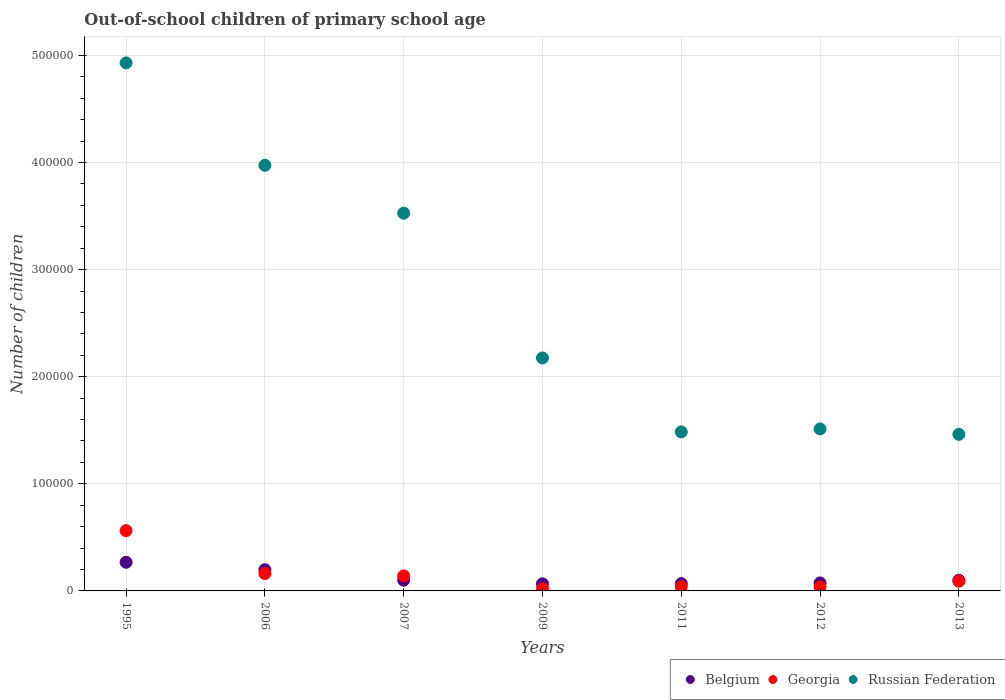What is the number of out-of-school children in Georgia in 2011?
Your answer should be very brief. 3975. Across all years, what is the maximum number of out-of-school children in Georgia?
Provide a succinct answer. 5.63e+04. Across all years, what is the minimum number of out-of-school children in Belgium?
Give a very brief answer. 6647. In which year was the number of out-of-school children in Russian Federation maximum?
Keep it short and to the point. 1995. What is the total number of out-of-school children in Belgium in the graph?
Your answer should be compact. 8.75e+04. What is the difference between the number of out-of-school children in Russian Federation in 1995 and that in 2013?
Your answer should be very brief. 3.47e+05. What is the difference between the number of out-of-school children in Georgia in 2006 and the number of out-of-school children in Russian Federation in 2007?
Give a very brief answer. -3.36e+05. What is the average number of out-of-school children in Georgia per year?
Your answer should be very brief. 1.50e+04. In the year 2013, what is the difference between the number of out-of-school children in Russian Federation and number of out-of-school children in Georgia?
Provide a short and direct response. 1.37e+05. What is the ratio of the number of out-of-school children in Russian Federation in 2006 to that in 2007?
Your answer should be very brief. 1.13. Is the difference between the number of out-of-school children in Russian Federation in 2009 and 2012 greater than the difference between the number of out-of-school children in Georgia in 2009 and 2012?
Give a very brief answer. Yes. What is the difference between the highest and the second highest number of out-of-school children in Russian Federation?
Your answer should be very brief. 9.57e+04. What is the difference between the highest and the lowest number of out-of-school children in Russian Federation?
Provide a short and direct response. 3.47e+05. Is the sum of the number of out-of-school children in Georgia in 1995 and 2009 greater than the maximum number of out-of-school children in Belgium across all years?
Your answer should be compact. Yes. Is it the case that in every year, the sum of the number of out-of-school children in Belgium and number of out-of-school children in Georgia  is greater than the number of out-of-school children in Russian Federation?
Your answer should be compact. No. Does the number of out-of-school children in Georgia monotonically increase over the years?
Provide a short and direct response. No. Is the number of out-of-school children in Russian Federation strictly greater than the number of out-of-school children in Belgium over the years?
Keep it short and to the point. Yes. Is the number of out-of-school children in Georgia strictly less than the number of out-of-school children in Russian Federation over the years?
Keep it short and to the point. Yes. How many dotlines are there?
Your answer should be very brief. 3. How many years are there in the graph?
Your answer should be very brief. 7. Where does the legend appear in the graph?
Offer a very short reply. Bottom right. What is the title of the graph?
Ensure brevity in your answer.  Out-of-school children of primary school age. Does "Latvia" appear as one of the legend labels in the graph?
Ensure brevity in your answer.  No. What is the label or title of the X-axis?
Provide a short and direct response. Years. What is the label or title of the Y-axis?
Keep it short and to the point. Number of children. What is the Number of children in Belgium in 1995?
Ensure brevity in your answer.  2.68e+04. What is the Number of children of Georgia in 1995?
Offer a very short reply. 5.63e+04. What is the Number of children in Russian Federation in 1995?
Provide a succinct answer. 4.93e+05. What is the Number of children of Belgium in 2006?
Your response must be concise. 1.98e+04. What is the Number of children in Georgia in 2006?
Keep it short and to the point. 1.63e+04. What is the Number of children of Russian Federation in 2006?
Provide a succinct answer. 3.97e+05. What is the Number of children in Belgium in 2007?
Your answer should be very brief. 1.00e+04. What is the Number of children in Georgia in 2007?
Your response must be concise. 1.40e+04. What is the Number of children of Russian Federation in 2007?
Provide a short and direct response. 3.53e+05. What is the Number of children of Belgium in 2009?
Offer a terse response. 6647. What is the Number of children of Georgia in 2009?
Your response must be concise. 1934. What is the Number of children of Russian Federation in 2009?
Ensure brevity in your answer.  2.18e+05. What is the Number of children in Belgium in 2011?
Keep it short and to the point. 6830. What is the Number of children of Georgia in 2011?
Keep it short and to the point. 3975. What is the Number of children of Russian Federation in 2011?
Provide a succinct answer. 1.48e+05. What is the Number of children in Belgium in 2012?
Provide a short and direct response. 7427. What is the Number of children in Georgia in 2012?
Your answer should be very brief. 3772. What is the Number of children in Russian Federation in 2012?
Your response must be concise. 1.51e+05. What is the Number of children of Belgium in 2013?
Ensure brevity in your answer.  9981. What is the Number of children in Georgia in 2013?
Your response must be concise. 9082. What is the Number of children in Russian Federation in 2013?
Provide a succinct answer. 1.46e+05. Across all years, what is the maximum Number of children in Belgium?
Offer a very short reply. 2.68e+04. Across all years, what is the maximum Number of children of Georgia?
Offer a terse response. 5.63e+04. Across all years, what is the maximum Number of children in Russian Federation?
Make the answer very short. 4.93e+05. Across all years, what is the minimum Number of children of Belgium?
Make the answer very short. 6647. Across all years, what is the minimum Number of children in Georgia?
Your answer should be compact. 1934. Across all years, what is the minimum Number of children in Russian Federation?
Keep it short and to the point. 1.46e+05. What is the total Number of children of Belgium in the graph?
Your answer should be compact. 8.75e+04. What is the total Number of children of Georgia in the graph?
Give a very brief answer. 1.05e+05. What is the total Number of children in Russian Federation in the graph?
Provide a succinct answer. 1.91e+06. What is the difference between the Number of children in Belgium in 1995 and that in 2006?
Your response must be concise. 6946. What is the difference between the Number of children in Georgia in 1995 and that in 2006?
Offer a terse response. 4.00e+04. What is the difference between the Number of children of Russian Federation in 1995 and that in 2006?
Your answer should be compact. 9.57e+04. What is the difference between the Number of children of Belgium in 1995 and that in 2007?
Offer a very short reply. 1.67e+04. What is the difference between the Number of children of Georgia in 1995 and that in 2007?
Offer a terse response. 4.22e+04. What is the difference between the Number of children of Russian Federation in 1995 and that in 2007?
Your answer should be compact. 1.40e+05. What is the difference between the Number of children of Belgium in 1995 and that in 2009?
Give a very brief answer. 2.01e+04. What is the difference between the Number of children of Georgia in 1995 and that in 2009?
Offer a terse response. 5.43e+04. What is the difference between the Number of children in Russian Federation in 1995 and that in 2009?
Offer a terse response. 2.76e+05. What is the difference between the Number of children of Belgium in 1995 and that in 2011?
Your answer should be very brief. 1.99e+04. What is the difference between the Number of children in Georgia in 1995 and that in 2011?
Offer a terse response. 5.23e+04. What is the difference between the Number of children in Russian Federation in 1995 and that in 2011?
Make the answer very short. 3.45e+05. What is the difference between the Number of children of Belgium in 1995 and that in 2012?
Make the answer very short. 1.93e+04. What is the difference between the Number of children of Georgia in 1995 and that in 2012?
Your answer should be very brief. 5.25e+04. What is the difference between the Number of children in Russian Federation in 1995 and that in 2012?
Offer a terse response. 3.42e+05. What is the difference between the Number of children in Belgium in 1995 and that in 2013?
Your answer should be compact. 1.68e+04. What is the difference between the Number of children in Georgia in 1995 and that in 2013?
Your response must be concise. 4.72e+04. What is the difference between the Number of children in Russian Federation in 1995 and that in 2013?
Offer a very short reply. 3.47e+05. What is the difference between the Number of children of Belgium in 2006 and that in 2007?
Offer a very short reply. 9786. What is the difference between the Number of children in Georgia in 2006 and that in 2007?
Offer a very short reply. 2213. What is the difference between the Number of children of Russian Federation in 2006 and that in 2007?
Ensure brevity in your answer.  4.47e+04. What is the difference between the Number of children of Belgium in 2006 and that in 2009?
Keep it short and to the point. 1.32e+04. What is the difference between the Number of children in Georgia in 2006 and that in 2009?
Provide a short and direct response. 1.43e+04. What is the difference between the Number of children in Russian Federation in 2006 and that in 2009?
Provide a succinct answer. 1.80e+05. What is the difference between the Number of children in Belgium in 2006 and that in 2011?
Offer a terse response. 1.30e+04. What is the difference between the Number of children in Georgia in 2006 and that in 2011?
Give a very brief answer. 1.23e+04. What is the difference between the Number of children of Russian Federation in 2006 and that in 2011?
Your response must be concise. 2.49e+05. What is the difference between the Number of children in Belgium in 2006 and that in 2012?
Provide a short and direct response. 1.24e+04. What is the difference between the Number of children of Georgia in 2006 and that in 2012?
Keep it short and to the point. 1.25e+04. What is the difference between the Number of children of Russian Federation in 2006 and that in 2012?
Keep it short and to the point. 2.46e+05. What is the difference between the Number of children in Belgium in 2006 and that in 2013?
Make the answer very short. 9828. What is the difference between the Number of children in Georgia in 2006 and that in 2013?
Ensure brevity in your answer.  7178. What is the difference between the Number of children in Russian Federation in 2006 and that in 2013?
Make the answer very short. 2.51e+05. What is the difference between the Number of children in Belgium in 2007 and that in 2009?
Ensure brevity in your answer.  3376. What is the difference between the Number of children in Georgia in 2007 and that in 2009?
Your response must be concise. 1.21e+04. What is the difference between the Number of children in Russian Federation in 2007 and that in 2009?
Your response must be concise. 1.35e+05. What is the difference between the Number of children of Belgium in 2007 and that in 2011?
Make the answer very short. 3193. What is the difference between the Number of children of Georgia in 2007 and that in 2011?
Provide a short and direct response. 1.01e+04. What is the difference between the Number of children of Russian Federation in 2007 and that in 2011?
Keep it short and to the point. 2.04e+05. What is the difference between the Number of children in Belgium in 2007 and that in 2012?
Make the answer very short. 2596. What is the difference between the Number of children of Georgia in 2007 and that in 2012?
Keep it short and to the point. 1.03e+04. What is the difference between the Number of children in Russian Federation in 2007 and that in 2012?
Give a very brief answer. 2.01e+05. What is the difference between the Number of children of Belgium in 2007 and that in 2013?
Keep it short and to the point. 42. What is the difference between the Number of children of Georgia in 2007 and that in 2013?
Offer a terse response. 4965. What is the difference between the Number of children in Russian Federation in 2007 and that in 2013?
Your response must be concise. 2.06e+05. What is the difference between the Number of children in Belgium in 2009 and that in 2011?
Make the answer very short. -183. What is the difference between the Number of children of Georgia in 2009 and that in 2011?
Provide a succinct answer. -2041. What is the difference between the Number of children of Russian Federation in 2009 and that in 2011?
Your answer should be compact. 6.90e+04. What is the difference between the Number of children in Belgium in 2009 and that in 2012?
Ensure brevity in your answer.  -780. What is the difference between the Number of children of Georgia in 2009 and that in 2012?
Provide a short and direct response. -1838. What is the difference between the Number of children in Russian Federation in 2009 and that in 2012?
Your answer should be compact. 6.63e+04. What is the difference between the Number of children of Belgium in 2009 and that in 2013?
Provide a succinct answer. -3334. What is the difference between the Number of children in Georgia in 2009 and that in 2013?
Make the answer very short. -7148. What is the difference between the Number of children in Russian Federation in 2009 and that in 2013?
Provide a succinct answer. 7.13e+04. What is the difference between the Number of children in Belgium in 2011 and that in 2012?
Your answer should be very brief. -597. What is the difference between the Number of children of Georgia in 2011 and that in 2012?
Your answer should be compact. 203. What is the difference between the Number of children of Russian Federation in 2011 and that in 2012?
Offer a very short reply. -2750. What is the difference between the Number of children in Belgium in 2011 and that in 2013?
Give a very brief answer. -3151. What is the difference between the Number of children in Georgia in 2011 and that in 2013?
Make the answer very short. -5107. What is the difference between the Number of children of Russian Federation in 2011 and that in 2013?
Make the answer very short. 2254. What is the difference between the Number of children of Belgium in 2012 and that in 2013?
Make the answer very short. -2554. What is the difference between the Number of children of Georgia in 2012 and that in 2013?
Offer a terse response. -5310. What is the difference between the Number of children in Russian Federation in 2012 and that in 2013?
Keep it short and to the point. 5004. What is the difference between the Number of children in Belgium in 1995 and the Number of children in Georgia in 2006?
Give a very brief answer. 1.05e+04. What is the difference between the Number of children of Belgium in 1995 and the Number of children of Russian Federation in 2006?
Offer a very short reply. -3.71e+05. What is the difference between the Number of children in Georgia in 1995 and the Number of children in Russian Federation in 2006?
Keep it short and to the point. -3.41e+05. What is the difference between the Number of children in Belgium in 1995 and the Number of children in Georgia in 2007?
Offer a very short reply. 1.27e+04. What is the difference between the Number of children of Belgium in 1995 and the Number of children of Russian Federation in 2007?
Offer a very short reply. -3.26e+05. What is the difference between the Number of children in Georgia in 1995 and the Number of children in Russian Federation in 2007?
Offer a very short reply. -2.96e+05. What is the difference between the Number of children in Belgium in 1995 and the Number of children in Georgia in 2009?
Your answer should be very brief. 2.48e+04. What is the difference between the Number of children of Belgium in 1995 and the Number of children of Russian Federation in 2009?
Give a very brief answer. -1.91e+05. What is the difference between the Number of children in Georgia in 1995 and the Number of children in Russian Federation in 2009?
Offer a very short reply. -1.61e+05. What is the difference between the Number of children of Belgium in 1995 and the Number of children of Georgia in 2011?
Keep it short and to the point. 2.28e+04. What is the difference between the Number of children in Belgium in 1995 and the Number of children in Russian Federation in 2011?
Provide a succinct answer. -1.22e+05. What is the difference between the Number of children in Georgia in 1995 and the Number of children in Russian Federation in 2011?
Keep it short and to the point. -9.22e+04. What is the difference between the Number of children in Belgium in 1995 and the Number of children in Georgia in 2012?
Make the answer very short. 2.30e+04. What is the difference between the Number of children of Belgium in 1995 and the Number of children of Russian Federation in 2012?
Provide a succinct answer. -1.24e+05. What is the difference between the Number of children of Georgia in 1995 and the Number of children of Russian Federation in 2012?
Provide a short and direct response. -9.50e+04. What is the difference between the Number of children of Belgium in 1995 and the Number of children of Georgia in 2013?
Offer a very short reply. 1.77e+04. What is the difference between the Number of children in Belgium in 1995 and the Number of children in Russian Federation in 2013?
Provide a short and direct response. -1.19e+05. What is the difference between the Number of children in Georgia in 1995 and the Number of children in Russian Federation in 2013?
Ensure brevity in your answer.  -9.00e+04. What is the difference between the Number of children of Belgium in 2006 and the Number of children of Georgia in 2007?
Offer a very short reply. 5762. What is the difference between the Number of children in Belgium in 2006 and the Number of children in Russian Federation in 2007?
Offer a terse response. -3.33e+05. What is the difference between the Number of children in Georgia in 2006 and the Number of children in Russian Federation in 2007?
Provide a short and direct response. -3.36e+05. What is the difference between the Number of children in Belgium in 2006 and the Number of children in Georgia in 2009?
Provide a short and direct response. 1.79e+04. What is the difference between the Number of children in Belgium in 2006 and the Number of children in Russian Federation in 2009?
Make the answer very short. -1.98e+05. What is the difference between the Number of children in Georgia in 2006 and the Number of children in Russian Federation in 2009?
Give a very brief answer. -2.01e+05. What is the difference between the Number of children in Belgium in 2006 and the Number of children in Georgia in 2011?
Offer a very short reply. 1.58e+04. What is the difference between the Number of children of Belgium in 2006 and the Number of children of Russian Federation in 2011?
Provide a succinct answer. -1.29e+05. What is the difference between the Number of children of Georgia in 2006 and the Number of children of Russian Federation in 2011?
Provide a short and direct response. -1.32e+05. What is the difference between the Number of children in Belgium in 2006 and the Number of children in Georgia in 2012?
Offer a very short reply. 1.60e+04. What is the difference between the Number of children of Belgium in 2006 and the Number of children of Russian Federation in 2012?
Ensure brevity in your answer.  -1.31e+05. What is the difference between the Number of children of Georgia in 2006 and the Number of children of Russian Federation in 2012?
Your answer should be compact. -1.35e+05. What is the difference between the Number of children of Belgium in 2006 and the Number of children of Georgia in 2013?
Your response must be concise. 1.07e+04. What is the difference between the Number of children of Belgium in 2006 and the Number of children of Russian Federation in 2013?
Your answer should be compact. -1.26e+05. What is the difference between the Number of children of Georgia in 2006 and the Number of children of Russian Federation in 2013?
Your answer should be compact. -1.30e+05. What is the difference between the Number of children of Belgium in 2007 and the Number of children of Georgia in 2009?
Your answer should be very brief. 8089. What is the difference between the Number of children in Belgium in 2007 and the Number of children in Russian Federation in 2009?
Offer a very short reply. -2.08e+05. What is the difference between the Number of children of Georgia in 2007 and the Number of children of Russian Federation in 2009?
Make the answer very short. -2.03e+05. What is the difference between the Number of children of Belgium in 2007 and the Number of children of Georgia in 2011?
Provide a succinct answer. 6048. What is the difference between the Number of children in Belgium in 2007 and the Number of children in Russian Federation in 2011?
Ensure brevity in your answer.  -1.38e+05. What is the difference between the Number of children of Georgia in 2007 and the Number of children of Russian Federation in 2011?
Make the answer very short. -1.34e+05. What is the difference between the Number of children in Belgium in 2007 and the Number of children in Georgia in 2012?
Provide a succinct answer. 6251. What is the difference between the Number of children of Belgium in 2007 and the Number of children of Russian Federation in 2012?
Provide a succinct answer. -1.41e+05. What is the difference between the Number of children of Georgia in 2007 and the Number of children of Russian Federation in 2012?
Your answer should be very brief. -1.37e+05. What is the difference between the Number of children of Belgium in 2007 and the Number of children of Georgia in 2013?
Provide a succinct answer. 941. What is the difference between the Number of children in Belgium in 2007 and the Number of children in Russian Federation in 2013?
Provide a succinct answer. -1.36e+05. What is the difference between the Number of children of Georgia in 2007 and the Number of children of Russian Federation in 2013?
Your response must be concise. -1.32e+05. What is the difference between the Number of children of Belgium in 2009 and the Number of children of Georgia in 2011?
Provide a succinct answer. 2672. What is the difference between the Number of children of Belgium in 2009 and the Number of children of Russian Federation in 2011?
Ensure brevity in your answer.  -1.42e+05. What is the difference between the Number of children of Georgia in 2009 and the Number of children of Russian Federation in 2011?
Keep it short and to the point. -1.47e+05. What is the difference between the Number of children of Belgium in 2009 and the Number of children of Georgia in 2012?
Make the answer very short. 2875. What is the difference between the Number of children in Belgium in 2009 and the Number of children in Russian Federation in 2012?
Your answer should be compact. -1.45e+05. What is the difference between the Number of children of Georgia in 2009 and the Number of children of Russian Federation in 2012?
Provide a short and direct response. -1.49e+05. What is the difference between the Number of children of Belgium in 2009 and the Number of children of Georgia in 2013?
Your response must be concise. -2435. What is the difference between the Number of children in Belgium in 2009 and the Number of children in Russian Federation in 2013?
Your answer should be compact. -1.40e+05. What is the difference between the Number of children of Georgia in 2009 and the Number of children of Russian Federation in 2013?
Keep it short and to the point. -1.44e+05. What is the difference between the Number of children in Belgium in 2011 and the Number of children in Georgia in 2012?
Give a very brief answer. 3058. What is the difference between the Number of children of Belgium in 2011 and the Number of children of Russian Federation in 2012?
Your answer should be compact. -1.44e+05. What is the difference between the Number of children in Georgia in 2011 and the Number of children in Russian Federation in 2012?
Your answer should be very brief. -1.47e+05. What is the difference between the Number of children of Belgium in 2011 and the Number of children of Georgia in 2013?
Make the answer very short. -2252. What is the difference between the Number of children of Belgium in 2011 and the Number of children of Russian Federation in 2013?
Make the answer very short. -1.39e+05. What is the difference between the Number of children of Georgia in 2011 and the Number of children of Russian Federation in 2013?
Make the answer very short. -1.42e+05. What is the difference between the Number of children of Belgium in 2012 and the Number of children of Georgia in 2013?
Offer a terse response. -1655. What is the difference between the Number of children in Belgium in 2012 and the Number of children in Russian Federation in 2013?
Give a very brief answer. -1.39e+05. What is the difference between the Number of children of Georgia in 2012 and the Number of children of Russian Federation in 2013?
Keep it short and to the point. -1.42e+05. What is the average Number of children in Belgium per year?
Offer a very short reply. 1.25e+04. What is the average Number of children in Georgia per year?
Make the answer very short. 1.50e+04. What is the average Number of children of Russian Federation per year?
Give a very brief answer. 2.72e+05. In the year 1995, what is the difference between the Number of children in Belgium and Number of children in Georgia?
Your answer should be very brief. -2.95e+04. In the year 1995, what is the difference between the Number of children of Belgium and Number of children of Russian Federation?
Provide a short and direct response. -4.66e+05. In the year 1995, what is the difference between the Number of children of Georgia and Number of children of Russian Federation?
Provide a short and direct response. -4.37e+05. In the year 2006, what is the difference between the Number of children of Belgium and Number of children of Georgia?
Provide a succinct answer. 3549. In the year 2006, what is the difference between the Number of children in Belgium and Number of children in Russian Federation?
Your answer should be very brief. -3.78e+05. In the year 2006, what is the difference between the Number of children in Georgia and Number of children in Russian Federation?
Ensure brevity in your answer.  -3.81e+05. In the year 2007, what is the difference between the Number of children of Belgium and Number of children of Georgia?
Give a very brief answer. -4024. In the year 2007, what is the difference between the Number of children in Belgium and Number of children in Russian Federation?
Your response must be concise. -3.43e+05. In the year 2007, what is the difference between the Number of children of Georgia and Number of children of Russian Federation?
Your answer should be compact. -3.39e+05. In the year 2009, what is the difference between the Number of children in Belgium and Number of children in Georgia?
Your answer should be compact. 4713. In the year 2009, what is the difference between the Number of children in Belgium and Number of children in Russian Federation?
Ensure brevity in your answer.  -2.11e+05. In the year 2009, what is the difference between the Number of children of Georgia and Number of children of Russian Federation?
Ensure brevity in your answer.  -2.16e+05. In the year 2011, what is the difference between the Number of children of Belgium and Number of children of Georgia?
Your response must be concise. 2855. In the year 2011, what is the difference between the Number of children in Belgium and Number of children in Russian Federation?
Ensure brevity in your answer.  -1.42e+05. In the year 2011, what is the difference between the Number of children in Georgia and Number of children in Russian Federation?
Offer a terse response. -1.45e+05. In the year 2012, what is the difference between the Number of children in Belgium and Number of children in Georgia?
Your response must be concise. 3655. In the year 2012, what is the difference between the Number of children of Belgium and Number of children of Russian Federation?
Your response must be concise. -1.44e+05. In the year 2012, what is the difference between the Number of children in Georgia and Number of children in Russian Federation?
Provide a short and direct response. -1.47e+05. In the year 2013, what is the difference between the Number of children in Belgium and Number of children in Georgia?
Provide a succinct answer. 899. In the year 2013, what is the difference between the Number of children in Belgium and Number of children in Russian Federation?
Keep it short and to the point. -1.36e+05. In the year 2013, what is the difference between the Number of children of Georgia and Number of children of Russian Federation?
Offer a very short reply. -1.37e+05. What is the ratio of the Number of children of Belgium in 1995 to that in 2006?
Your answer should be very brief. 1.35. What is the ratio of the Number of children in Georgia in 1995 to that in 2006?
Make the answer very short. 3.46. What is the ratio of the Number of children in Russian Federation in 1995 to that in 2006?
Your answer should be compact. 1.24. What is the ratio of the Number of children of Belgium in 1995 to that in 2007?
Ensure brevity in your answer.  2.67. What is the ratio of the Number of children in Georgia in 1995 to that in 2007?
Keep it short and to the point. 4.01. What is the ratio of the Number of children in Russian Federation in 1995 to that in 2007?
Make the answer very short. 1.4. What is the ratio of the Number of children in Belgium in 1995 to that in 2009?
Your answer should be very brief. 4.03. What is the ratio of the Number of children in Georgia in 1995 to that in 2009?
Offer a very short reply. 29.09. What is the ratio of the Number of children of Russian Federation in 1995 to that in 2009?
Make the answer very short. 2.27. What is the ratio of the Number of children in Belgium in 1995 to that in 2011?
Offer a terse response. 3.92. What is the ratio of the Number of children of Georgia in 1995 to that in 2011?
Your answer should be very brief. 14.15. What is the ratio of the Number of children of Russian Federation in 1995 to that in 2011?
Ensure brevity in your answer.  3.32. What is the ratio of the Number of children of Belgium in 1995 to that in 2012?
Ensure brevity in your answer.  3.6. What is the ratio of the Number of children of Georgia in 1995 to that in 2012?
Provide a short and direct response. 14.92. What is the ratio of the Number of children in Russian Federation in 1995 to that in 2012?
Your answer should be compact. 3.26. What is the ratio of the Number of children in Belgium in 1995 to that in 2013?
Keep it short and to the point. 2.68. What is the ratio of the Number of children in Georgia in 1995 to that in 2013?
Offer a very short reply. 6.2. What is the ratio of the Number of children in Russian Federation in 1995 to that in 2013?
Offer a terse response. 3.37. What is the ratio of the Number of children in Belgium in 2006 to that in 2007?
Give a very brief answer. 1.98. What is the ratio of the Number of children of Georgia in 2006 to that in 2007?
Make the answer very short. 1.16. What is the ratio of the Number of children in Russian Federation in 2006 to that in 2007?
Offer a terse response. 1.13. What is the ratio of the Number of children of Belgium in 2006 to that in 2009?
Ensure brevity in your answer.  2.98. What is the ratio of the Number of children in Georgia in 2006 to that in 2009?
Your response must be concise. 8.41. What is the ratio of the Number of children of Russian Federation in 2006 to that in 2009?
Your answer should be very brief. 1.83. What is the ratio of the Number of children of Belgium in 2006 to that in 2011?
Offer a very short reply. 2.9. What is the ratio of the Number of children of Georgia in 2006 to that in 2011?
Keep it short and to the point. 4.09. What is the ratio of the Number of children in Russian Federation in 2006 to that in 2011?
Offer a terse response. 2.68. What is the ratio of the Number of children of Belgium in 2006 to that in 2012?
Offer a very short reply. 2.67. What is the ratio of the Number of children of Georgia in 2006 to that in 2012?
Give a very brief answer. 4.31. What is the ratio of the Number of children of Russian Federation in 2006 to that in 2012?
Offer a terse response. 2.63. What is the ratio of the Number of children in Belgium in 2006 to that in 2013?
Keep it short and to the point. 1.98. What is the ratio of the Number of children in Georgia in 2006 to that in 2013?
Provide a short and direct response. 1.79. What is the ratio of the Number of children of Russian Federation in 2006 to that in 2013?
Keep it short and to the point. 2.72. What is the ratio of the Number of children in Belgium in 2007 to that in 2009?
Offer a terse response. 1.51. What is the ratio of the Number of children of Georgia in 2007 to that in 2009?
Ensure brevity in your answer.  7.26. What is the ratio of the Number of children in Russian Federation in 2007 to that in 2009?
Give a very brief answer. 1.62. What is the ratio of the Number of children in Belgium in 2007 to that in 2011?
Your response must be concise. 1.47. What is the ratio of the Number of children of Georgia in 2007 to that in 2011?
Ensure brevity in your answer.  3.53. What is the ratio of the Number of children in Russian Federation in 2007 to that in 2011?
Provide a succinct answer. 2.38. What is the ratio of the Number of children in Belgium in 2007 to that in 2012?
Make the answer very short. 1.35. What is the ratio of the Number of children of Georgia in 2007 to that in 2012?
Provide a short and direct response. 3.72. What is the ratio of the Number of children of Russian Federation in 2007 to that in 2012?
Offer a terse response. 2.33. What is the ratio of the Number of children in Belgium in 2007 to that in 2013?
Offer a terse response. 1. What is the ratio of the Number of children of Georgia in 2007 to that in 2013?
Ensure brevity in your answer.  1.55. What is the ratio of the Number of children of Russian Federation in 2007 to that in 2013?
Provide a short and direct response. 2.41. What is the ratio of the Number of children of Belgium in 2009 to that in 2011?
Make the answer very short. 0.97. What is the ratio of the Number of children in Georgia in 2009 to that in 2011?
Ensure brevity in your answer.  0.49. What is the ratio of the Number of children in Russian Federation in 2009 to that in 2011?
Provide a short and direct response. 1.47. What is the ratio of the Number of children in Belgium in 2009 to that in 2012?
Ensure brevity in your answer.  0.9. What is the ratio of the Number of children in Georgia in 2009 to that in 2012?
Keep it short and to the point. 0.51. What is the ratio of the Number of children of Russian Federation in 2009 to that in 2012?
Provide a succinct answer. 1.44. What is the ratio of the Number of children of Belgium in 2009 to that in 2013?
Your response must be concise. 0.67. What is the ratio of the Number of children in Georgia in 2009 to that in 2013?
Keep it short and to the point. 0.21. What is the ratio of the Number of children of Russian Federation in 2009 to that in 2013?
Keep it short and to the point. 1.49. What is the ratio of the Number of children in Belgium in 2011 to that in 2012?
Give a very brief answer. 0.92. What is the ratio of the Number of children in Georgia in 2011 to that in 2012?
Offer a terse response. 1.05. What is the ratio of the Number of children of Russian Federation in 2011 to that in 2012?
Your answer should be very brief. 0.98. What is the ratio of the Number of children of Belgium in 2011 to that in 2013?
Keep it short and to the point. 0.68. What is the ratio of the Number of children of Georgia in 2011 to that in 2013?
Your answer should be very brief. 0.44. What is the ratio of the Number of children of Russian Federation in 2011 to that in 2013?
Your answer should be very brief. 1.02. What is the ratio of the Number of children of Belgium in 2012 to that in 2013?
Your answer should be compact. 0.74. What is the ratio of the Number of children of Georgia in 2012 to that in 2013?
Keep it short and to the point. 0.42. What is the ratio of the Number of children in Russian Federation in 2012 to that in 2013?
Offer a very short reply. 1.03. What is the difference between the highest and the second highest Number of children of Belgium?
Offer a terse response. 6946. What is the difference between the highest and the second highest Number of children in Georgia?
Your answer should be compact. 4.00e+04. What is the difference between the highest and the second highest Number of children in Russian Federation?
Keep it short and to the point. 9.57e+04. What is the difference between the highest and the lowest Number of children of Belgium?
Offer a very short reply. 2.01e+04. What is the difference between the highest and the lowest Number of children of Georgia?
Give a very brief answer. 5.43e+04. What is the difference between the highest and the lowest Number of children of Russian Federation?
Your response must be concise. 3.47e+05. 